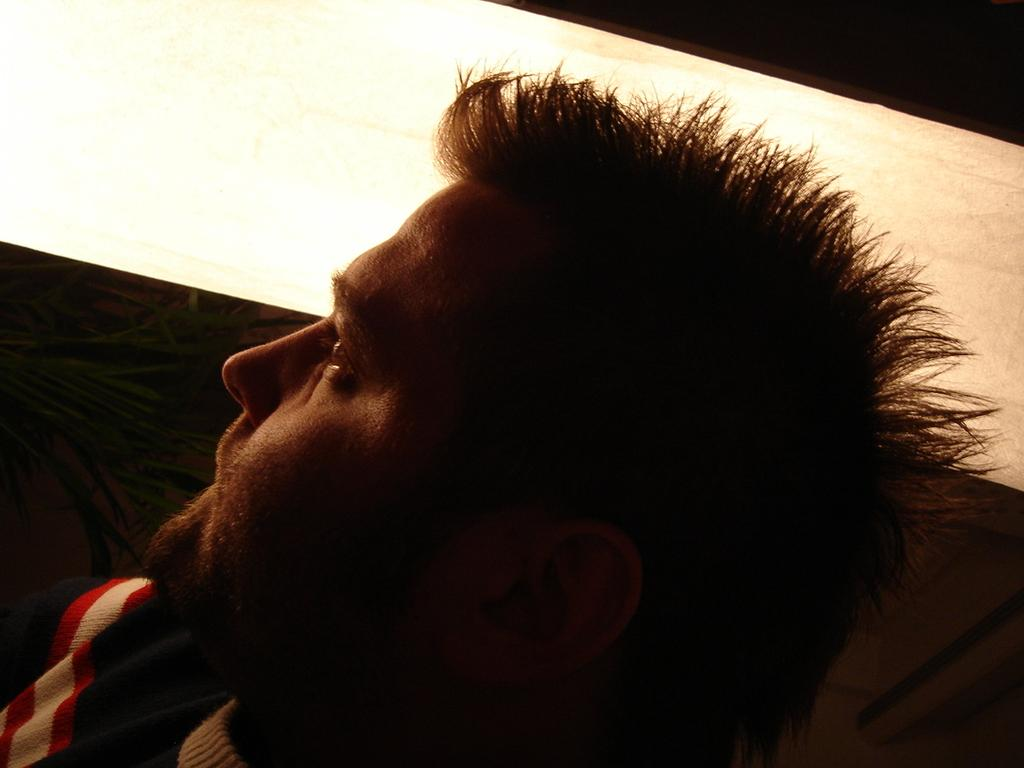Who is present in the image? There is a man in the image. What can be seen in the background of the image? There is a plant in the background of the image. What type of amusement can be seen in the image? There is no amusement present in the image; it features a man and a plant in the background. What time of day is depicted in the image, given the presence of a bean? There is no bean present in the image, and the time of day cannot be determined from the image alone. 